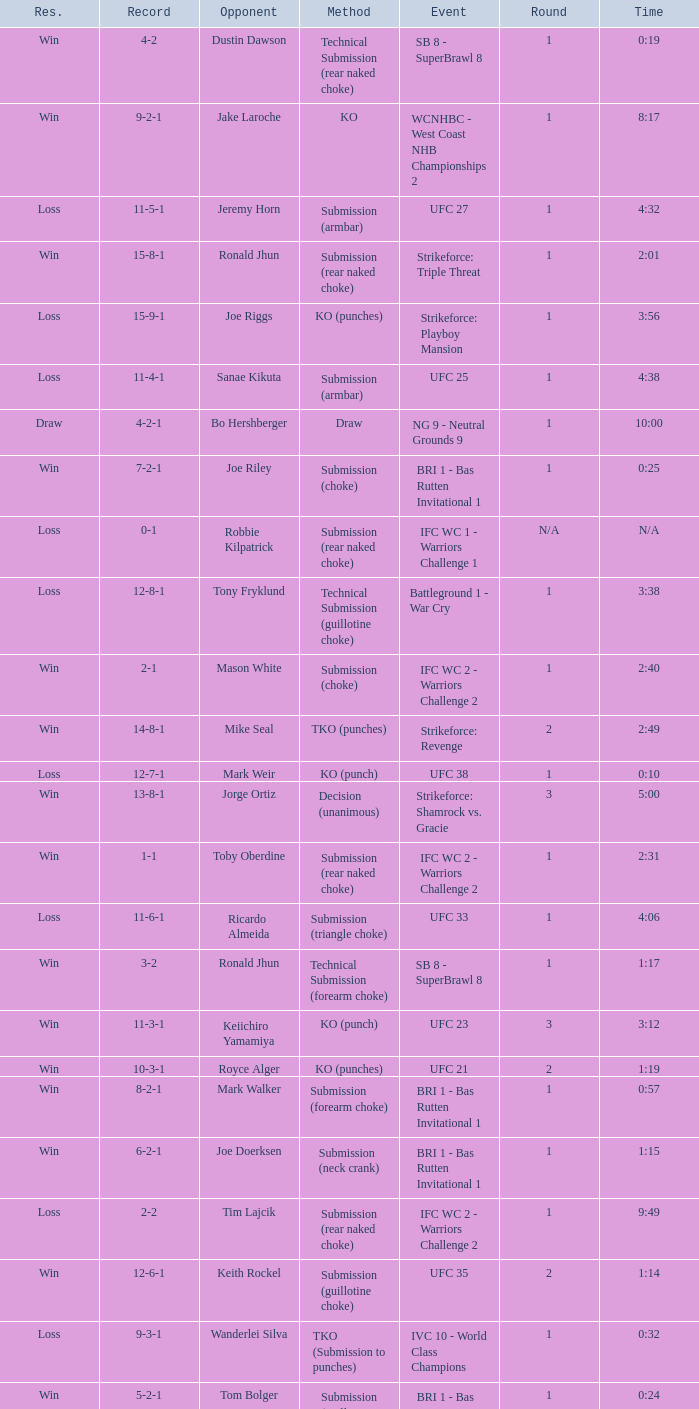Who was the opponent when the fight had a time of 2:01? Ronald Jhun. 